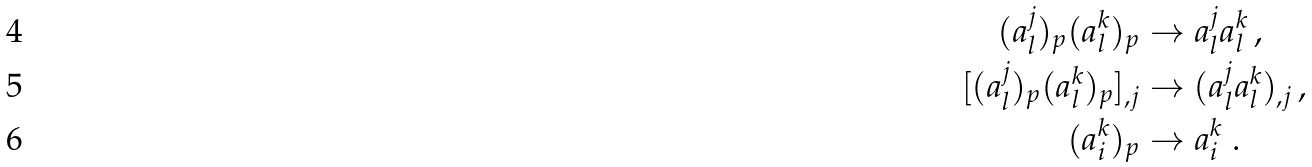<formula> <loc_0><loc_0><loc_500><loc_500>( a ^ { j } _ { l } ) _ { p } ( a ^ { k } _ { l } ) _ { p } & \rightarrow a ^ { j } _ { l } a ^ { k } _ { l } \, , \\ [ ( a ^ { j } _ { l } ) _ { p } ( a ^ { k } _ { l } ) _ { p } ] _ { , j } & \rightarrow ( a ^ { j } _ { l } a ^ { k } _ { l } ) _ { , j } \, , \\ ( a ^ { k } _ { i } ) _ { p } & \rightarrow a ^ { k } _ { i } \ .</formula> 